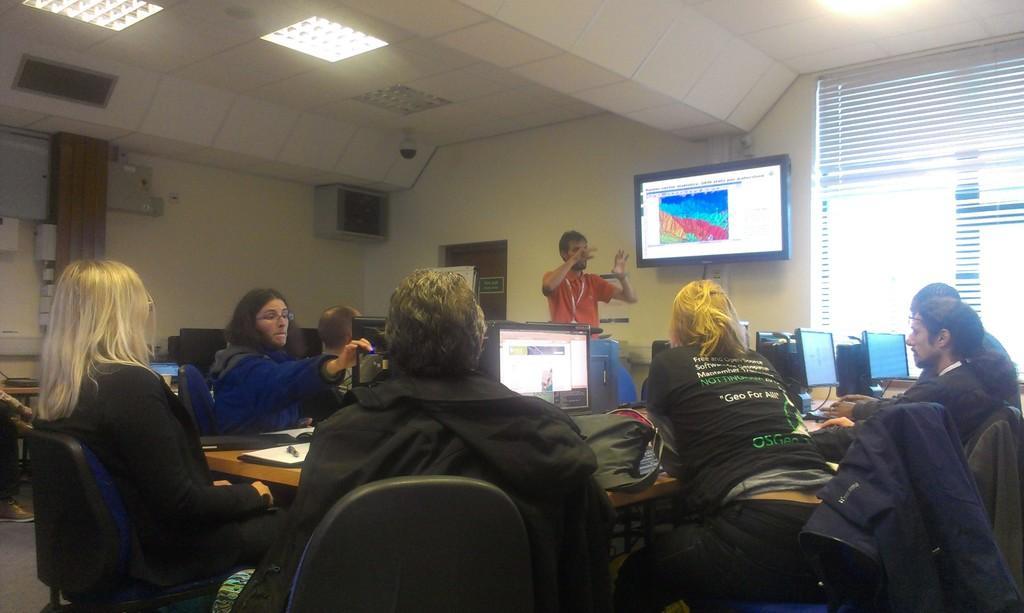Can you describe this image briefly? In this picture I can see few people are seated on the chairs and I can see few monitors, a bag, books and few keyboards on the table and I can see a television to the wall and a man standing and speaking and I can see few monitors on the side and lights to the ceiling and blinds to the window. 